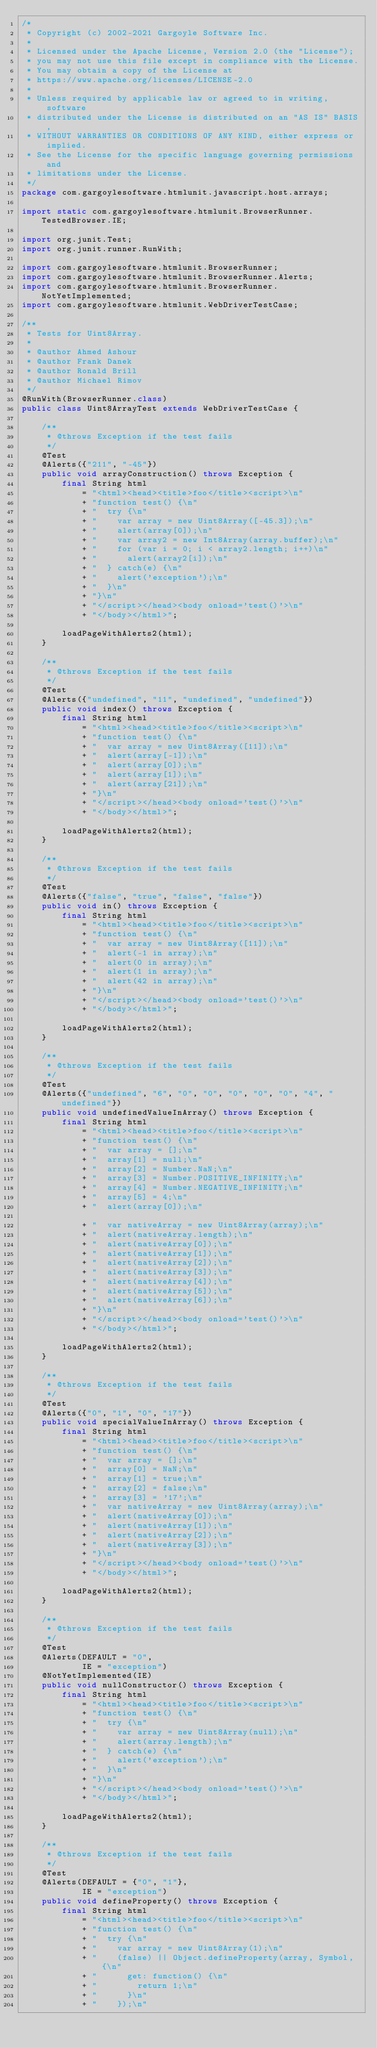Convert code to text. <code><loc_0><loc_0><loc_500><loc_500><_Java_>/*
 * Copyright (c) 2002-2021 Gargoyle Software Inc.
 *
 * Licensed under the Apache License, Version 2.0 (the "License");
 * you may not use this file except in compliance with the License.
 * You may obtain a copy of the License at
 * https://www.apache.org/licenses/LICENSE-2.0
 *
 * Unless required by applicable law or agreed to in writing, software
 * distributed under the License is distributed on an "AS IS" BASIS,
 * WITHOUT WARRANTIES OR CONDITIONS OF ANY KIND, either express or implied.
 * See the License for the specific language governing permissions and
 * limitations under the License.
 */
package com.gargoylesoftware.htmlunit.javascript.host.arrays;

import static com.gargoylesoftware.htmlunit.BrowserRunner.TestedBrowser.IE;

import org.junit.Test;
import org.junit.runner.RunWith;

import com.gargoylesoftware.htmlunit.BrowserRunner;
import com.gargoylesoftware.htmlunit.BrowserRunner.Alerts;
import com.gargoylesoftware.htmlunit.BrowserRunner.NotYetImplemented;
import com.gargoylesoftware.htmlunit.WebDriverTestCase;

/**
 * Tests for Uint8Array.
 *
 * @author Ahmed Ashour
 * @author Frank Danek
 * @author Ronald Brill
 * @author Michael Rimov
 */
@RunWith(BrowserRunner.class)
public class Uint8ArrayTest extends WebDriverTestCase {

    /**
     * @throws Exception if the test fails
     */
    @Test
    @Alerts({"211", "-45"})
    public void arrayConstruction() throws Exception {
        final String html
            = "<html><head><title>foo</title><script>\n"
            + "function test() {\n"
            + "  try {\n"
            + "    var array = new Uint8Array([-45.3]);\n"
            + "    alert(array[0]);\n"
            + "    var array2 = new Int8Array(array.buffer);\n"
            + "    for (var i = 0; i < array2.length; i++)\n"
            + "      alert(array2[i]);\n"
            + "  } catch(e) {\n"
            + "    alert('exception');\n"
            + "  }\n"
            + "}\n"
            + "</script></head><body onload='test()'>\n"
            + "</body></html>";

        loadPageWithAlerts2(html);
    }

    /**
     * @throws Exception if the test fails
     */
    @Test
    @Alerts({"undefined", "11", "undefined", "undefined"})
    public void index() throws Exception {
        final String html
            = "<html><head><title>foo</title><script>\n"
            + "function test() {\n"
            + "  var array = new Uint8Array([11]);\n"
            + "  alert(array[-1]);\n"
            + "  alert(array[0]);\n"
            + "  alert(array[1]);\n"
            + "  alert(array[21]);\n"
            + "}\n"
            + "</script></head><body onload='test()'>\n"
            + "</body></html>";

        loadPageWithAlerts2(html);
    }

    /**
     * @throws Exception if the test fails
     */
    @Test
    @Alerts({"false", "true", "false", "false"})
    public void in() throws Exception {
        final String html
            = "<html><head><title>foo</title><script>\n"
            + "function test() {\n"
            + "  var array = new Uint8Array([11]);\n"
            + "  alert(-1 in array);\n"
            + "  alert(0 in array);\n"
            + "  alert(1 in array);\n"
            + "  alert(42 in array);\n"
            + "}\n"
            + "</script></head><body onload='test()'>\n"
            + "</body></html>";

        loadPageWithAlerts2(html);
    }

    /**
     * @throws Exception if the test fails
     */
    @Test
    @Alerts({"undefined", "6", "0", "0", "0", "0", "0", "4", "undefined"})
    public void undefinedValueInArray() throws Exception {
        final String html
            = "<html><head><title>foo</title><script>\n"
            + "function test() {\n"
            + "  var array = [];\n"
            + "  array[1] = null;\n"
            + "  array[2] = Number.NaN;\n"
            + "  array[3] = Number.POSITIVE_INFINITY;\n"
            + "  array[4] = Number.NEGATIVE_INFINITY;\n"
            + "  array[5] = 4;\n"
            + "  alert(array[0]);\n"

            + "  var nativeArray = new Uint8Array(array);\n"
            + "  alert(nativeArray.length);\n"
            + "  alert(nativeArray[0]);\n"
            + "  alert(nativeArray[1]);\n"
            + "  alert(nativeArray[2]);\n"
            + "  alert(nativeArray[3]);\n"
            + "  alert(nativeArray[4]);\n"
            + "  alert(nativeArray[5]);\n"
            + "  alert(nativeArray[6]);\n"
            + "}\n"
            + "</script></head><body onload='test()'>\n"
            + "</body></html>";

        loadPageWithAlerts2(html);
    }

    /**
     * @throws Exception if the test fails
     */
    @Test
    @Alerts({"0", "1", "0", "17"})
    public void specialValueInArray() throws Exception {
        final String html
            = "<html><head><title>foo</title><script>\n"
            + "function test() {\n"
            + "  var array = [];\n"
            + "  array[0] = NaN;\n"
            + "  array[1] = true;\n"
            + "  array[2] = false;\n"
            + "  array[3] = '17';\n"
            + "  var nativeArray = new Uint8Array(array);\n"
            + "  alert(nativeArray[0]);\n"
            + "  alert(nativeArray[1]);\n"
            + "  alert(nativeArray[2]);\n"
            + "  alert(nativeArray[3]);\n"
            + "}\n"
            + "</script></head><body onload='test()'>\n"
            + "</body></html>";

        loadPageWithAlerts2(html);
    }

    /**
     * @throws Exception if the test fails
     */
    @Test
    @Alerts(DEFAULT = "0",
            IE = "exception")
    @NotYetImplemented(IE)
    public void nullConstructor() throws Exception {
        final String html
            = "<html><head><title>foo</title><script>\n"
            + "function test() {\n"
            + "  try {\n"
            + "    var array = new Uint8Array(null);\n"
            + "    alert(array.length);\n"
            + "  } catch(e) {\n"
            + "    alert('exception');\n"
            + "  }\n"
            + "}\n"
            + "</script></head><body onload='test()'>\n"
            + "</body></html>";

        loadPageWithAlerts2(html);
    }

    /**
     * @throws Exception if the test fails
     */
    @Test
    @Alerts(DEFAULT = {"0", "1"},
            IE = "exception")
    public void defineProperty() throws Exception {
        final String html
            = "<html><head><title>foo</title><script>\n"
            + "function test() {\n"
            + "  try {\n"
            + "    var array = new Uint8Array(1);\n"
            + "    (false) || Object.defineProperty(array, Symbol, {\n"
            + "      get: function() {\n"
            + "        return 1;\n"
            + "      }\n"
            + "    });\n"</code> 